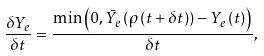Convert formula to latex. <formula><loc_0><loc_0><loc_500><loc_500>\frac { \delta Y _ { e } } { \delta t } = \frac { \min \left ( 0 , \bar { Y } _ { e } \left ( \rho \left ( t + \delta t \right ) \right ) - Y _ { e } \left ( t \right ) \right ) } { \delta t } ,</formula> 